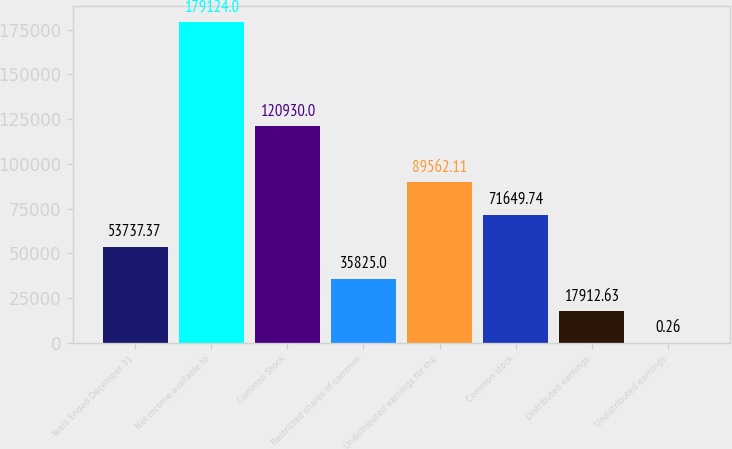Convert chart. <chart><loc_0><loc_0><loc_500><loc_500><bar_chart><fcel>Years Ended December 31<fcel>Net income available to<fcel>Common Stock<fcel>Restricted shares of common<fcel>Undistributed earnings for the<fcel>Common stock<fcel>Distributed earnings<fcel>Undistributed earnings<nl><fcel>53737.4<fcel>179124<fcel>120930<fcel>35825<fcel>89562.1<fcel>71649.7<fcel>17912.6<fcel>0.26<nl></chart> 